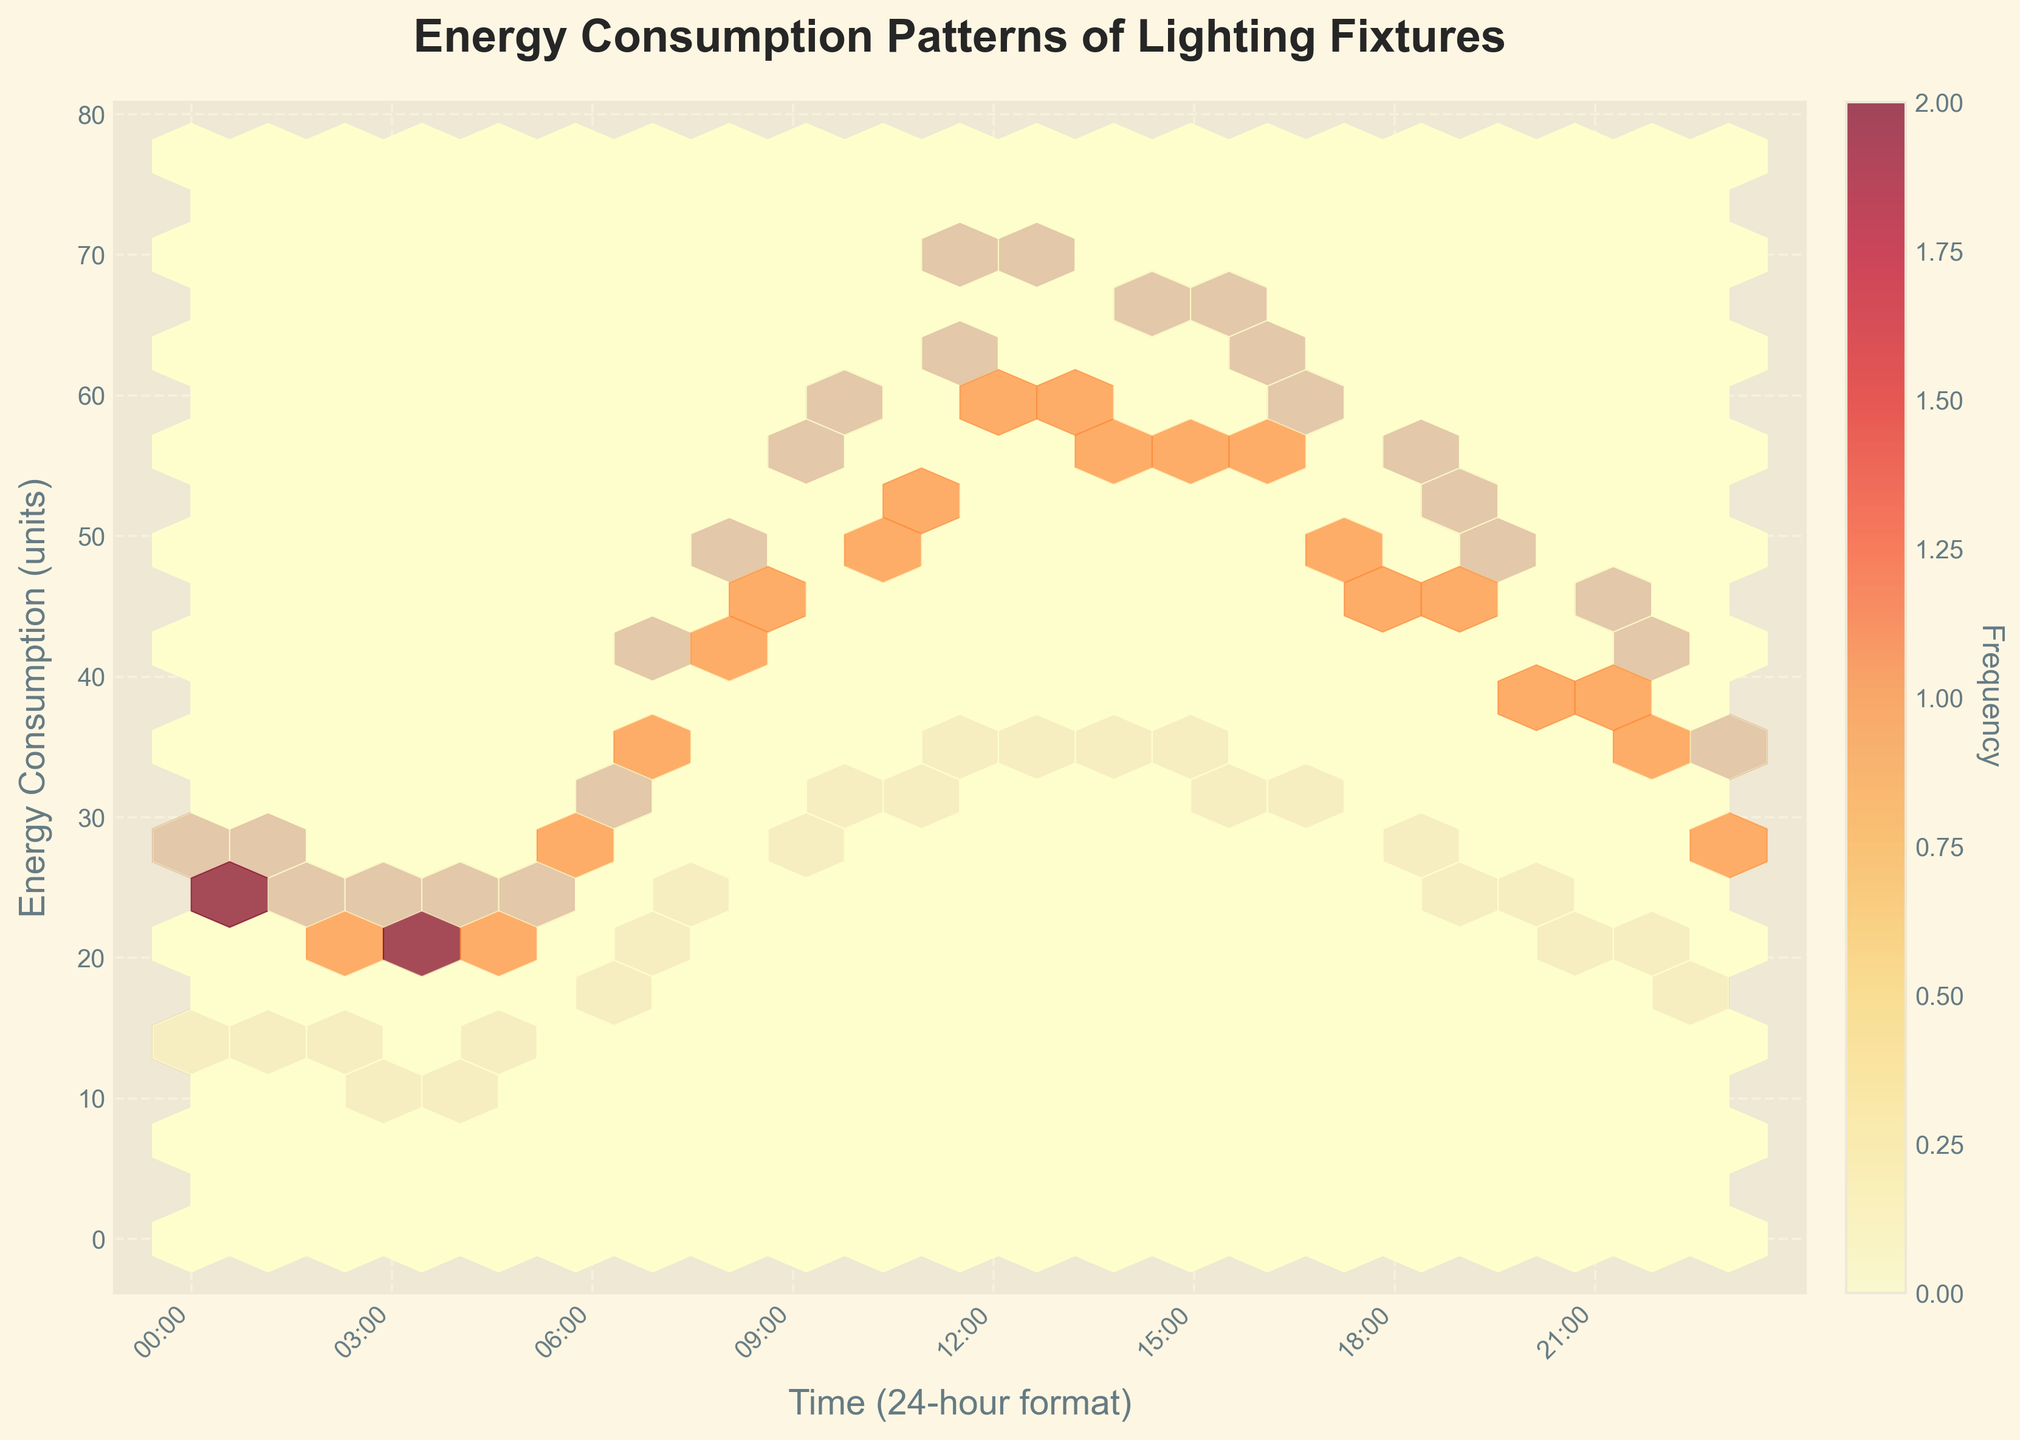What is the title of the plot? The title of the plot is written on top of the figure.
Answer: Energy Consumption Patterns of Lighting Fixtures What is the label on the x-axis? The x-axis label is written beneath the x-axis.
Answer: Time (24-hour format) What is the color scheme used in the hexbin plot? The color scheme can be seen visually in the plot. It starts from lighter yellow to darker red.
Answer: YlOrRd How often are the ticks marked on the x-axis? By observing the x-axis, the ticks are marked at intervals.
Answer: Every 3 hours What's the highest frequency shown in the color bar? The color bar indicates the frequency and its range, located beside the main plot.
Answer: Around 6 Which lighting fixture consumes the most energy at 12:00 PM? By observing the hexbin density at 12:00 PM on the plot and checking the corresponding energy values, the Halogen Track Light shows the highest density.
Answer: Halogen Track Light Comparing LED Spotlight and Halogen Track Light, which one has the lowest energy consumption during 10:00 PM? Refer to the plot to find the energy consumption values for both lighting fixtures at 10:00 PM.
Answer: LED Spotlight On average, how does the energy consumption of Fluorescent Tubes change from 6:00 AM to 6:00 PM? To find the average change in energy consumption, check the hexbin densities at 6:00 AM and 6:00 PM and calculate the average change.
Answer: Increases What is the time range where all types of lighting fixtures see a significant rise in energy consumption? Observe the plot for the time range within which the density hexes increase significantly for all fixtures.
Answer: 6:00 AM to 12:00 PM How does the energy consumption pattern of Fluorescent Tubes compare to that of Halogen Track Lights throughout the day? By comparing the densities throughout the 24 hours for both light fixtures across the plot, we can summarize their general trends.
Answer: Fluorescent Tubes have lower energy consumption and smoother patterns than Halogen Track Lights, which peak higher and show more fluctuations 